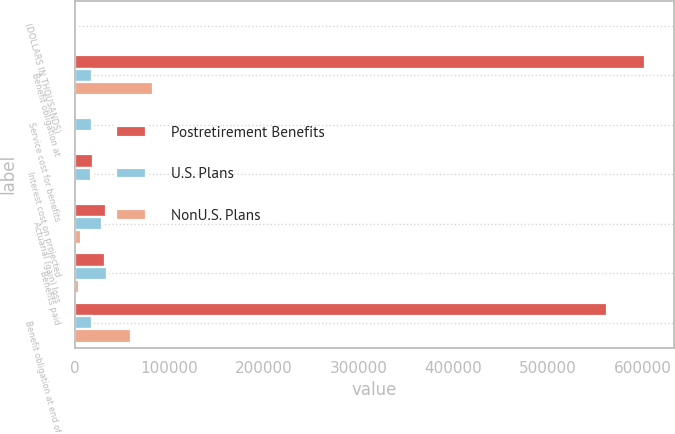Convert chart. <chart><loc_0><loc_0><loc_500><loc_500><stacked_bar_chart><ecel><fcel>(DOLLARS IN THOUSANDS)<fcel>Benefit obligation at<fcel>Service cost for benefits<fcel>Interest cost on projected<fcel>Actuarial (gain) loss<fcel>Benefits paid<fcel>Benefit obligation at end of<nl><fcel>Postretirement Benefits<fcel>2018<fcel>602783<fcel>1971<fcel>19393<fcel>33284<fcel>32093<fcel>562043<nl><fcel>U.S. Plans<fcel>2018<fcel>18738<fcel>18738<fcel>17704<fcel>29433<fcel>33862<fcel>18738<nl><fcel>NonU.S. Plans<fcel>2018<fcel>82714<fcel>755<fcel>2460<fcel>6677<fcel>5200<fcel>59625<nl></chart> 